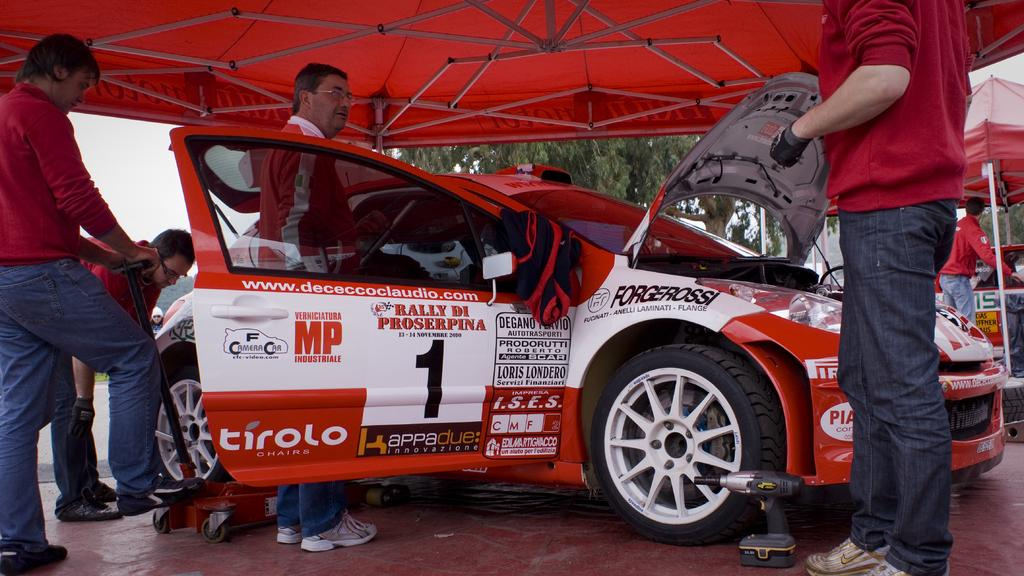What is the main subject of the image? The main subject of the image is a car. Can you describe the car's appearance? The car is white and red in color. What else can be seen in the image besides the car? There are people standing around the car, and a tree is visible in the background of the image. Is there a cannon in the park that is causing pollution in the image? There is no park, cannon, or pollution mentioned or visible in the image. The image features a car, people, and a tree in the background. 